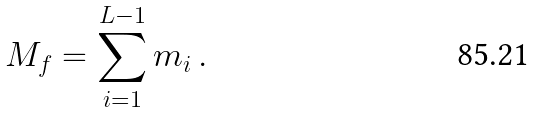<formula> <loc_0><loc_0><loc_500><loc_500>M _ { f } = \sum _ { i = 1 } ^ { L - 1 } m _ { i } \, .</formula> 